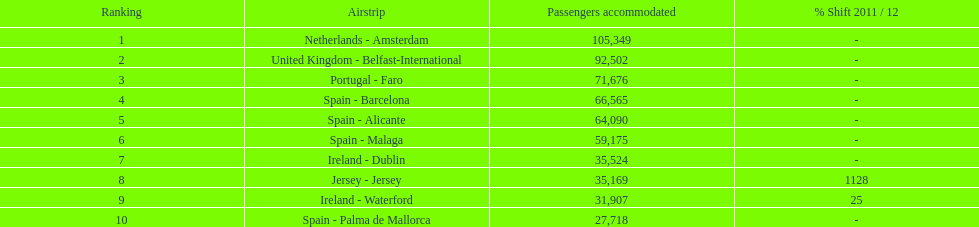I'm looking to parse the entire table for insights. Could you assist me with that? {'header': ['Ranking', 'Airstrip', 'Passengers accommodated', '% Shift 2011 / 12'], 'rows': [['1', 'Netherlands - Amsterdam', '105,349', '-'], ['2', 'United Kingdom - Belfast-International', '92,502', '-'], ['3', 'Portugal - Faro', '71,676', '-'], ['4', 'Spain - Barcelona', '66,565', '-'], ['5', 'Spain - Alicante', '64,090', '-'], ['6', 'Spain - Malaga', '59,175', '-'], ['7', 'Ireland - Dublin', '35,524', '-'], ['8', 'Jersey - Jersey', '35,169', '1128'], ['9', 'Ireland - Waterford', '31,907', '25'], ['10', 'Spain - Palma de Mallorca', '27,718', '-']]} How many passengers are going to or coming from spain? 217,548. 